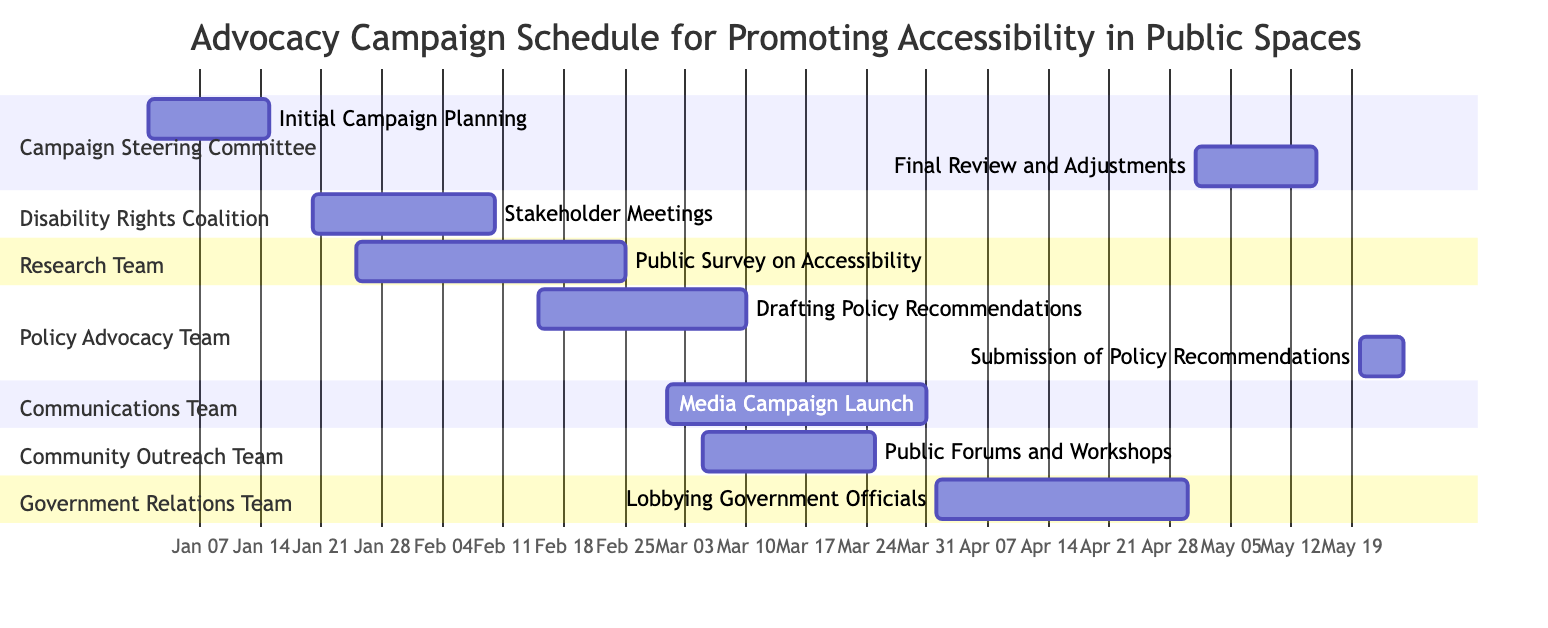What is the duration of the "Public Survey on Accessibility"? The "Public Survey on Accessibility" starts on January 25, 2024, and ends on February 25, 2024. To calculate the duration, we subtract the start date from the end date, resulting in 31 days.
Answer: 31 days Which team is responsible for "Lobbying Government Officials"? By examining the diagram, we see the task "Lobbying Government Officials" is listed under the "Government Relations Team." The responsible party corresponds to the team designated for that specific task.
Answer: Government Relations Team How many tasks are scheduled in March 2024? Looking at the tasks scheduled for March 2024, we identify the following: "Media Campaign Launch" (March 1-31), "Public Forums and Workshops" (March 5-25), and "Drafting Policy Recommendations" (February 15-March 10). The tasks that have parts in March total three.
Answer: 3 What task follows the "Stakeholder Meetings"? The "Stakeholder Meetings" end on February 10, 2024. The next task in chronological order is "Public Survey on Accessibility," which begins on January 25, but it overlaps. However, the direct task that happens after "Stakeholder Meetings" is the "Drafting Policy Recommendations," starting on February 15, 2024.
Answer: Drafting Policy Recommendations When does the "Media Campaign Launch" begin? The "Media Campaign Launch" is clearly labeled with a start date on the diagram. It starts on March 1, 2024. This information is displayed prominently under its designated section.
Answer: March 1, 2024 Which task has the latest end date? To find the latest end date, we compare the end dates of all tasks. The latest date among them is "Lobbying Government Officials," which concludes on April 30, 2024, indicating it is the final task in the schedule.
Answer: April 30, 2024 